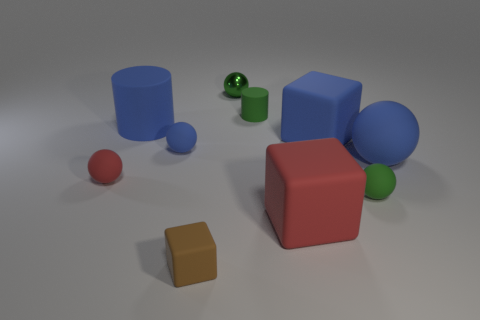What number of green rubber objects are in front of the small green rubber object that is on the right side of the large red thing?
Provide a succinct answer. 0. What color is the cylinder that is the same size as the green metal sphere?
Offer a terse response. Green. There is a big object behind the blue rubber cube; what is it made of?
Provide a short and direct response. Rubber. There is a blue thing that is to the left of the large red matte object and to the right of the blue cylinder; what material is it?
Provide a short and direct response. Rubber. There is a green sphere behind the red sphere; is it the same size as the tiny green cylinder?
Provide a short and direct response. Yes. What is the shape of the big red matte thing?
Keep it short and to the point. Cube. How many other objects are the same shape as the small brown matte thing?
Your answer should be compact. 2. What number of green things are in front of the large blue cylinder and behind the blue cube?
Give a very brief answer. 0. What color is the tiny shiny object?
Make the answer very short. Green. Is there a green thing that has the same material as the small cylinder?
Your response must be concise. Yes. 